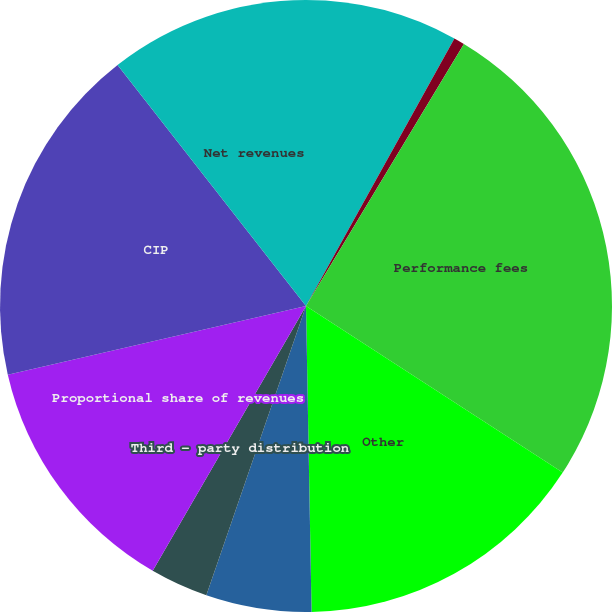Convert chart to OTSL. <chart><loc_0><loc_0><loc_500><loc_500><pie_chart><fcel>Investment management fees<fcel>Service and distribution fees<fcel>Performance fees<fcel>Other<fcel>Total operating revenues<fcel>Third - party distribution<fcel>Proportional share of revenues<fcel>CIP<fcel>Net revenues<nl><fcel>8.06%<fcel>0.57%<fcel>25.53%<fcel>15.55%<fcel>5.57%<fcel>3.07%<fcel>13.05%<fcel>18.04%<fcel>10.56%<nl></chart> 